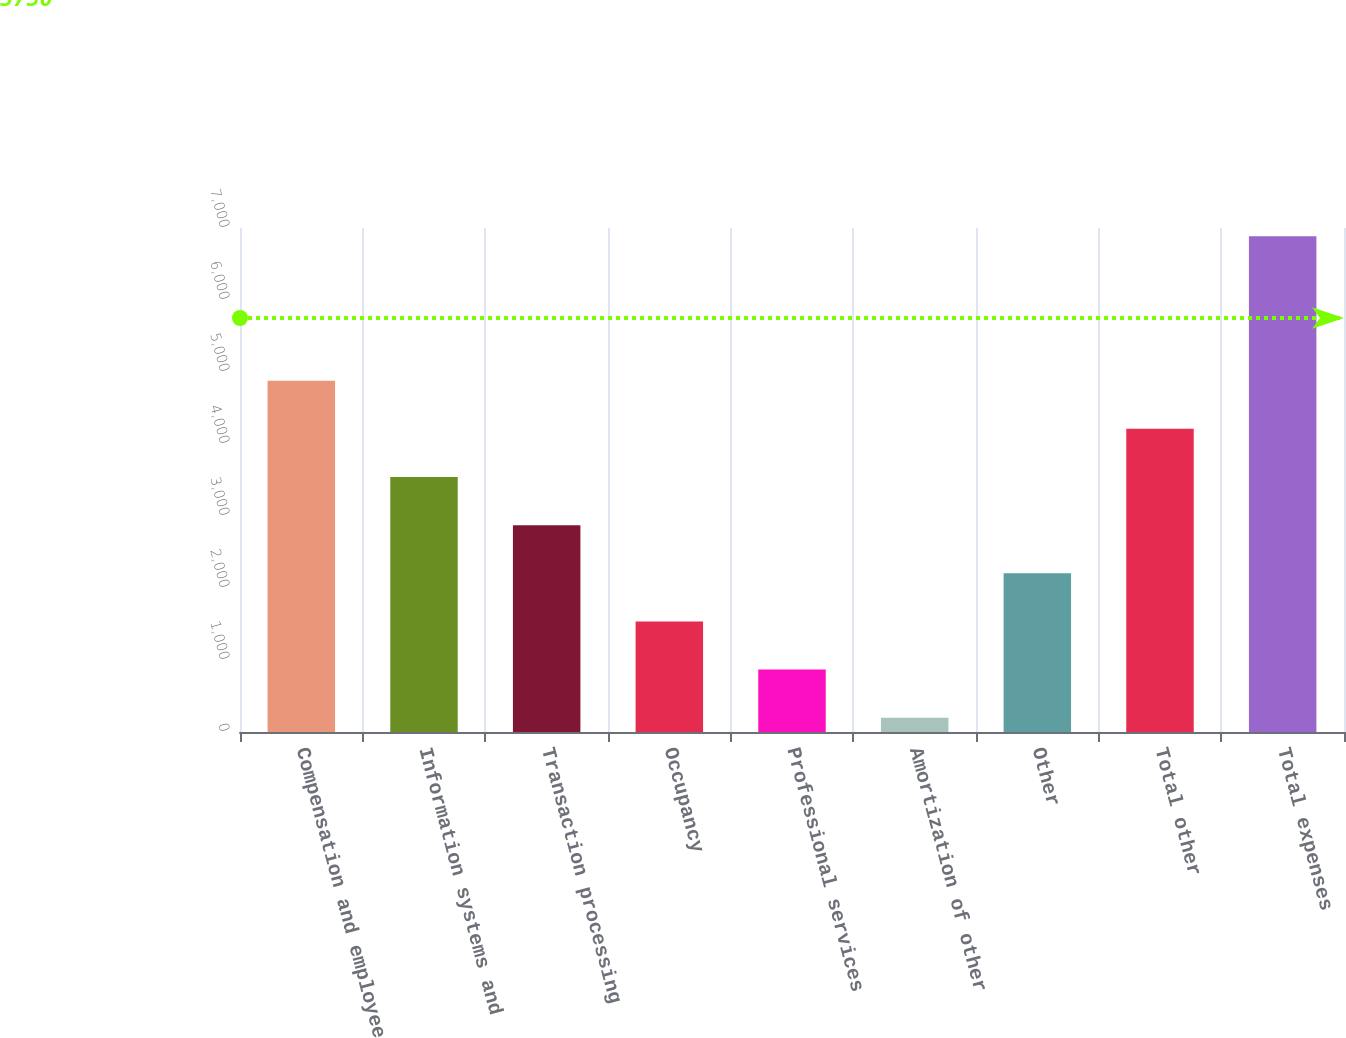Convert chart. <chart><loc_0><loc_0><loc_500><loc_500><bar_chart><fcel>Compensation and employee<fcel>Information systems and<fcel>Transaction processing<fcel>Occupancy<fcel>Professional services<fcel>Amortization of other<fcel>Other<fcel>Total other<fcel>Total expenses<nl><fcel>4879.6<fcel>3542<fcel>2873.2<fcel>1535.6<fcel>866.8<fcel>198<fcel>2204.4<fcel>4210.8<fcel>6886<nl></chart> 